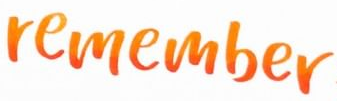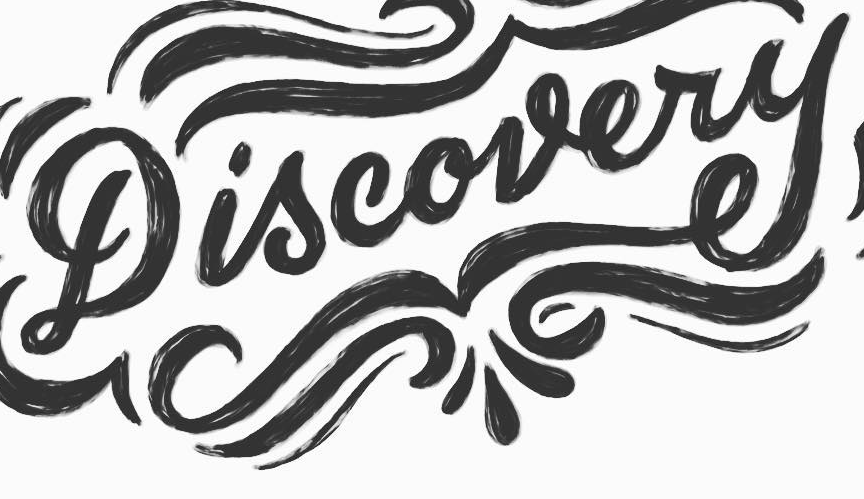Identify the words shown in these images in order, separated by a semicolon. remember; Discovery 